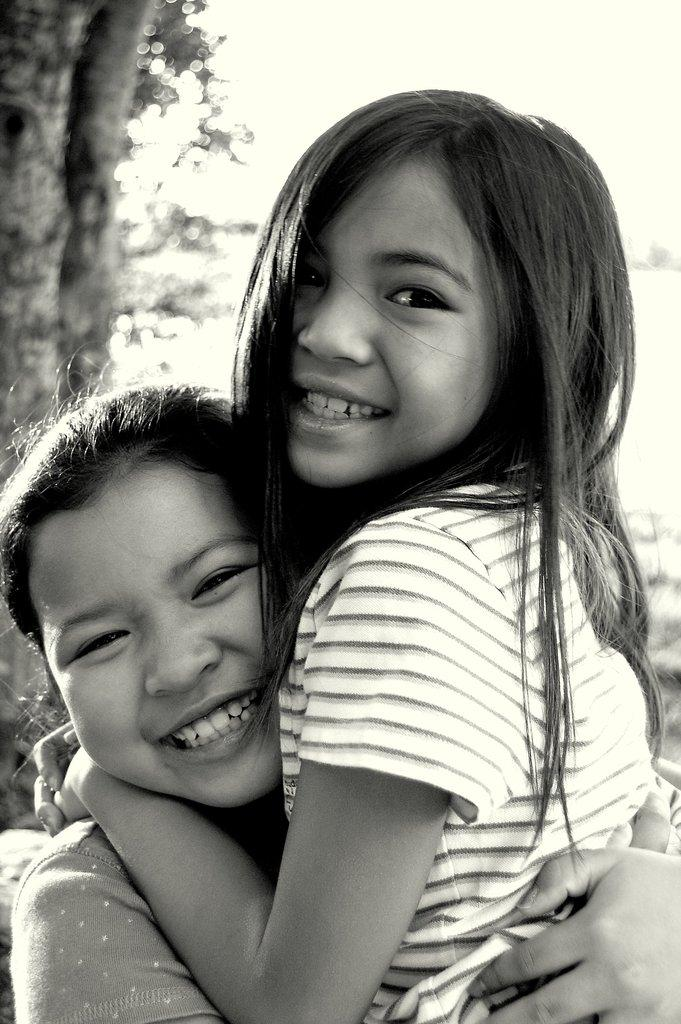Who or what is present in the image? There are people in the image. What is the emotional state of the people in the image? The people are smiling. What can be seen in the background of the image? There are trees visible in the background of the image. What is the color scheme of the image? The image is in black and white. What type of fruit is being consumed by the people in the image? There is no fruit visible in the image, and it is not mentioned that the people are consuming anything. How does the behavior of the people in the image compare to their behavior in a different setting? We cannot compare the behavior of the people in the image to their behavior in a different setting, as we do not have any information about their behavior in other situations. 